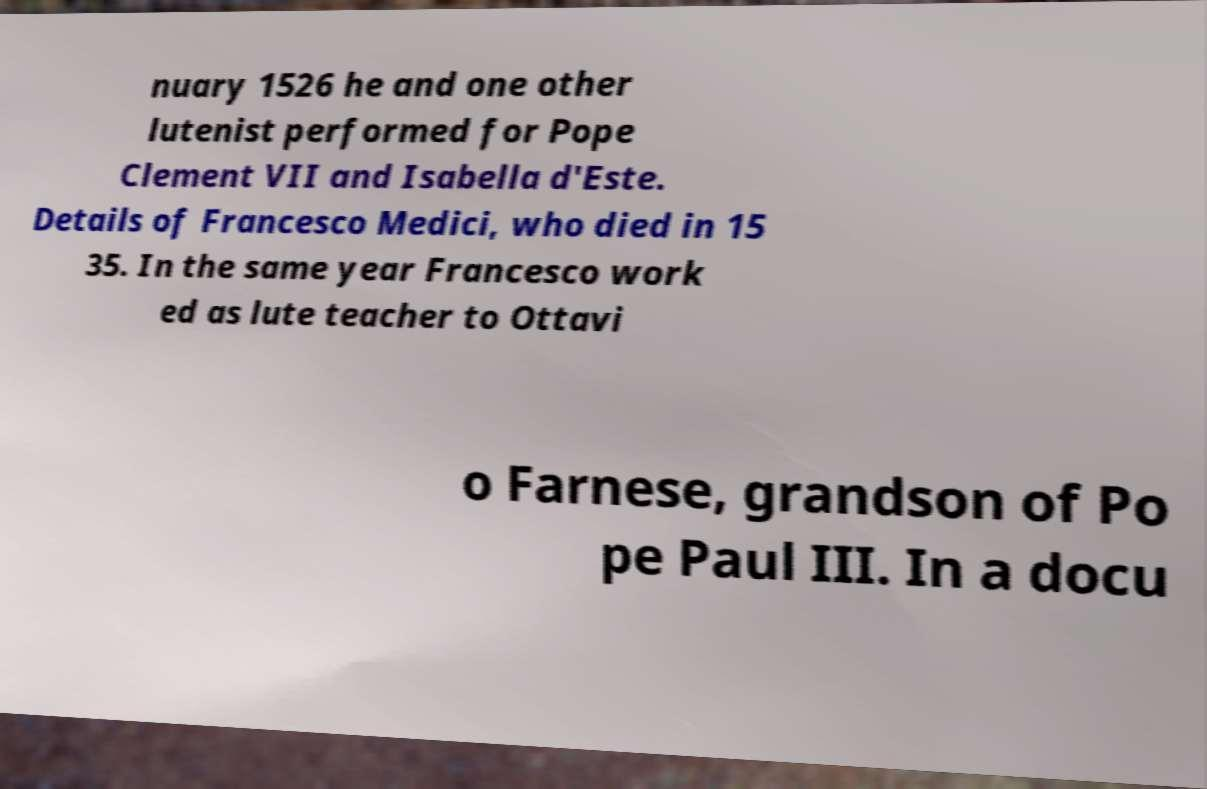Please read and relay the text visible in this image. What does it say? nuary 1526 he and one other lutenist performed for Pope Clement VII and Isabella d'Este. Details of Francesco Medici, who died in 15 35. In the same year Francesco work ed as lute teacher to Ottavi o Farnese, grandson of Po pe Paul III. In a docu 